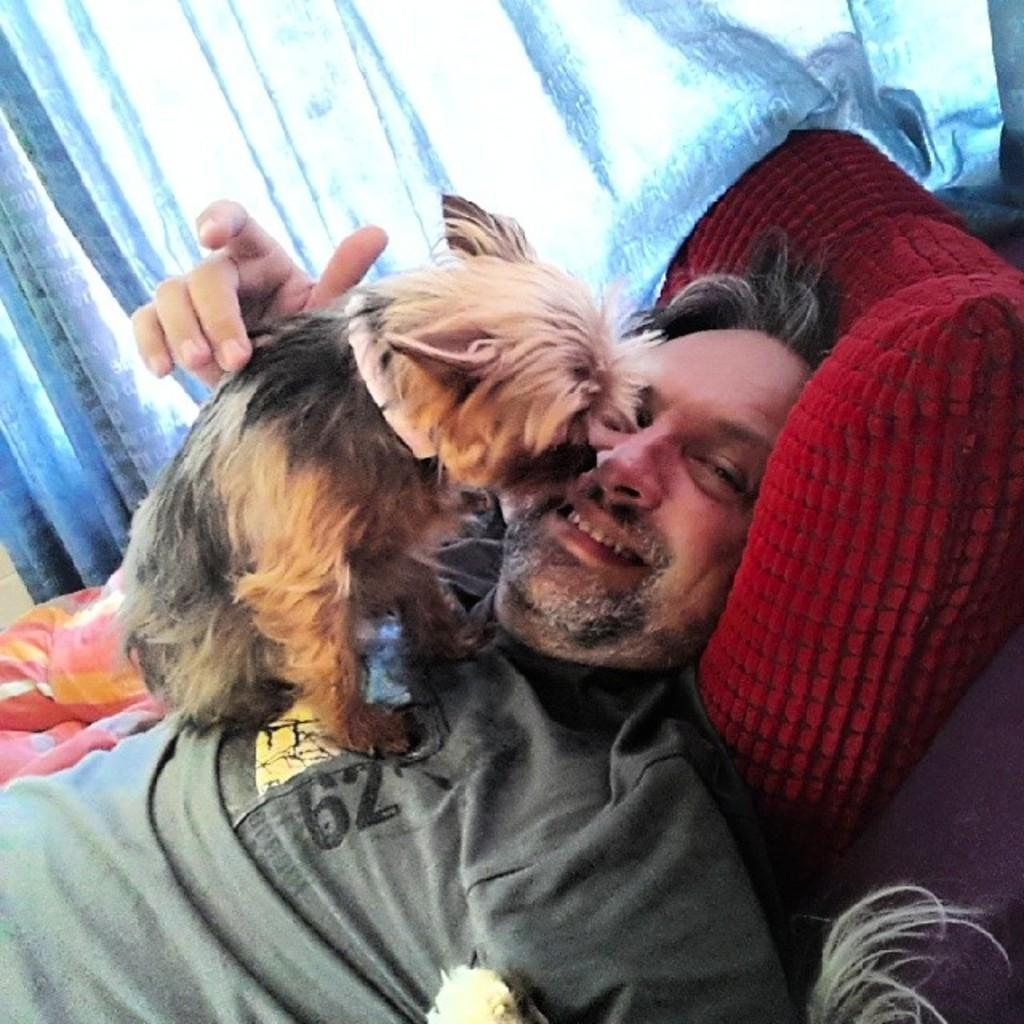What is the man in the image doing? The man is lying on the bed and pampering the dog. What is on top of the man in the image? There is a dog on the man. What can be seen in the background of the image? There is a white color curtain in the background of the image. What type of roof can be seen in the image? There is no roof visible in the image; it only shows a man lying on the bed with a dog on him and a white color curtain in the background. Can you tell me how many yaks are present in the image? There are no yaks present in the image. 